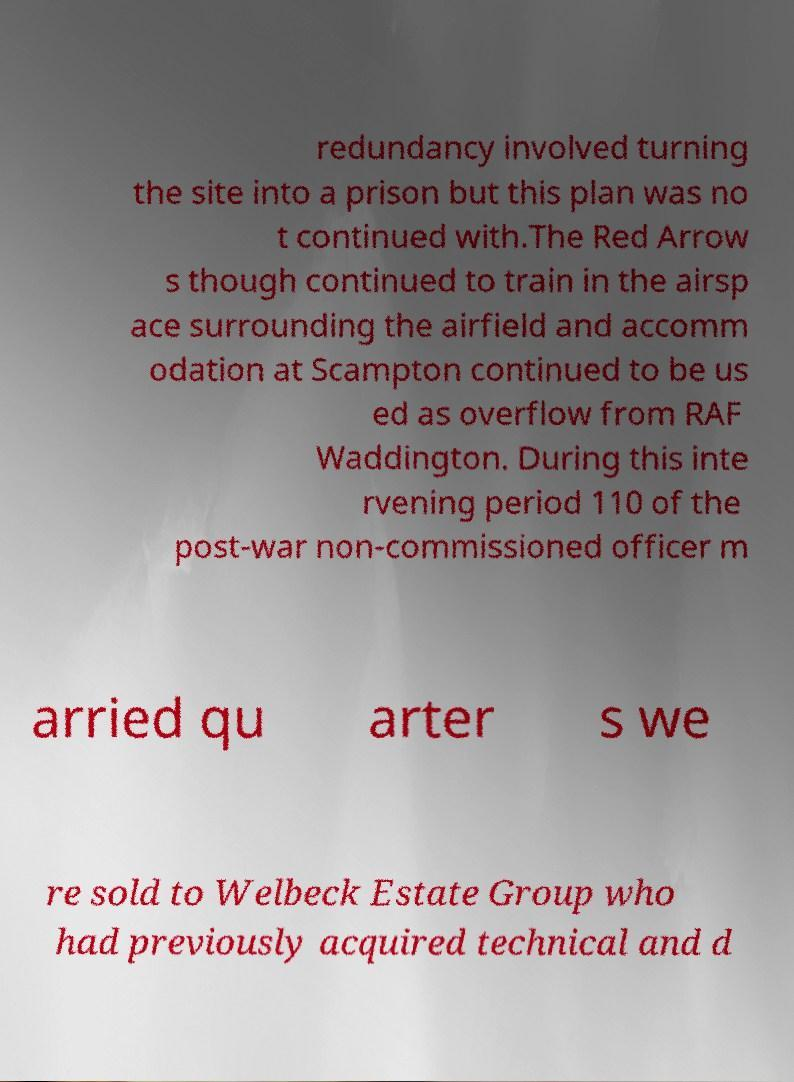Can you read and provide the text displayed in the image?This photo seems to have some interesting text. Can you extract and type it out for me? redundancy involved turning the site into a prison but this plan was no t continued with.The Red Arrow s though continued to train in the airsp ace surrounding the airfield and accomm odation at Scampton continued to be us ed as overflow from RAF Waddington. During this inte rvening period 110 of the post-war non-commissioned officer m arried qu arter s we re sold to Welbeck Estate Group who had previously acquired technical and d 